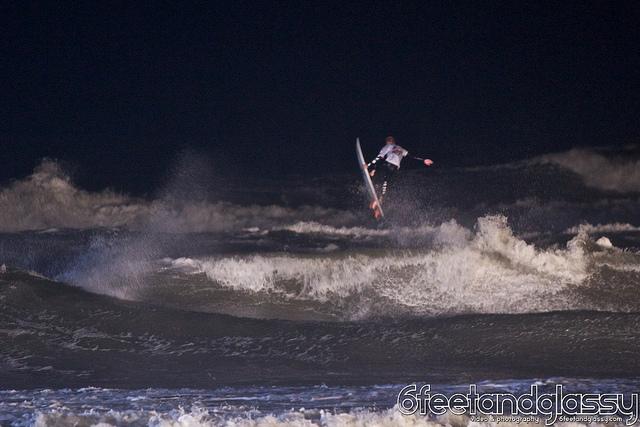Is it night time?
Quick response, please. Yes. What is the weather like?
Give a very brief answer. Windy. What kind of body of water is this?
Give a very brief answer. Ocean. What color is the wetsuit?
Short answer required. Black. Is the lightning flash close to the surfer?
Keep it brief. No. Is the guy higher than the waves?
Answer briefly. Yes. What color is surfer's wetsuit?
Short answer required. White. 